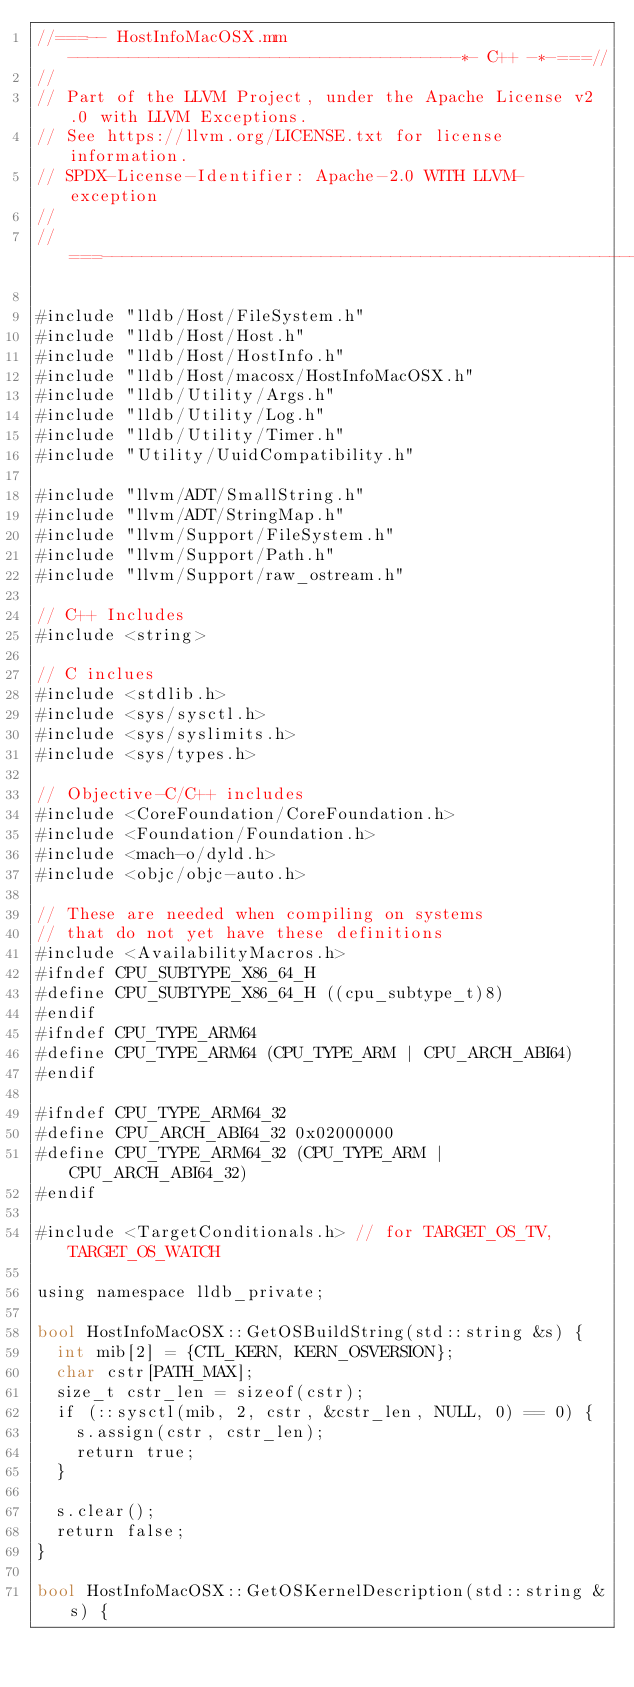Convert code to text. <code><loc_0><loc_0><loc_500><loc_500><_ObjectiveC_>//===-- HostInfoMacOSX.mm ---------------------------------------*- C++ -*-===//
//
// Part of the LLVM Project, under the Apache License v2.0 with LLVM Exceptions.
// See https://llvm.org/LICENSE.txt for license information.
// SPDX-License-Identifier: Apache-2.0 WITH LLVM-exception
//
//===----------------------------------------------------------------------===//

#include "lldb/Host/FileSystem.h"
#include "lldb/Host/Host.h"
#include "lldb/Host/HostInfo.h"
#include "lldb/Host/macosx/HostInfoMacOSX.h"
#include "lldb/Utility/Args.h"
#include "lldb/Utility/Log.h"
#include "lldb/Utility/Timer.h"
#include "Utility/UuidCompatibility.h"

#include "llvm/ADT/SmallString.h"
#include "llvm/ADT/StringMap.h"
#include "llvm/Support/FileSystem.h"
#include "llvm/Support/Path.h"
#include "llvm/Support/raw_ostream.h"

// C++ Includes
#include <string>

// C inclues
#include <stdlib.h>
#include <sys/sysctl.h>
#include <sys/syslimits.h>
#include <sys/types.h>

// Objective-C/C++ includes
#include <CoreFoundation/CoreFoundation.h>
#include <Foundation/Foundation.h>
#include <mach-o/dyld.h>
#include <objc/objc-auto.h>

// These are needed when compiling on systems
// that do not yet have these definitions
#include <AvailabilityMacros.h>
#ifndef CPU_SUBTYPE_X86_64_H
#define CPU_SUBTYPE_X86_64_H ((cpu_subtype_t)8)
#endif
#ifndef CPU_TYPE_ARM64
#define CPU_TYPE_ARM64 (CPU_TYPE_ARM | CPU_ARCH_ABI64)
#endif

#ifndef CPU_TYPE_ARM64_32
#define CPU_ARCH_ABI64_32 0x02000000
#define CPU_TYPE_ARM64_32 (CPU_TYPE_ARM | CPU_ARCH_ABI64_32)
#endif

#include <TargetConditionals.h> // for TARGET_OS_TV, TARGET_OS_WATCH

using namespace lldb_private;

bool HostInfoMacOSX::GetOSBuildString(std::string &s) {
  int mib[2] = {CTL_KERN, KERN_OSVERSION};
  char cstr[PATH_MAX];
  size_t cstr_len = sizeof(cstr);
  if (::sysctl(mib, 2, cstr, &cstr_len, NULL, 0) == 0) {
    s.assign(cstr, cstr_len);
    return true;
  }

  s.clear();
  return false;
}

bool HostInfoMacOSX::GetOSKernelDescription(std::string &s) {</code> 